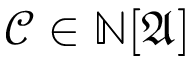Convert formula to latex. <formula><loc_0><loc_0><loc_500><loc_500>{ \mathcal { C } } \in \mathbb { N } [ { \mathfrak { A } } ]</formula> 